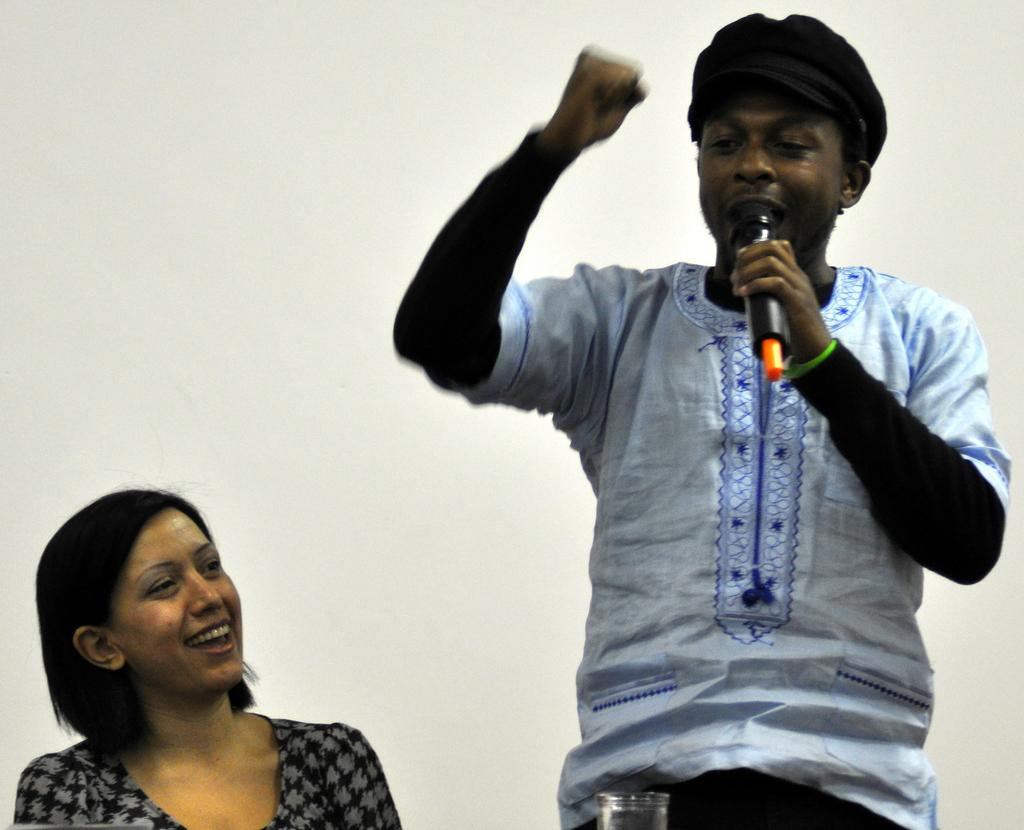How many people are in the image? There are two persons in the image. What is the position of one of the persons? One person is standing. What is the standing person holding? The standing person is holding a microphone. Can you describe an object in the image? There is a glass in the image. What can be seen in the background of the image? There is a wall in the background of the image. What type of hook is being used to taste the microphone in the image? There is no hook or tasting of the microphone in the image; the standing person is simply holding it. 